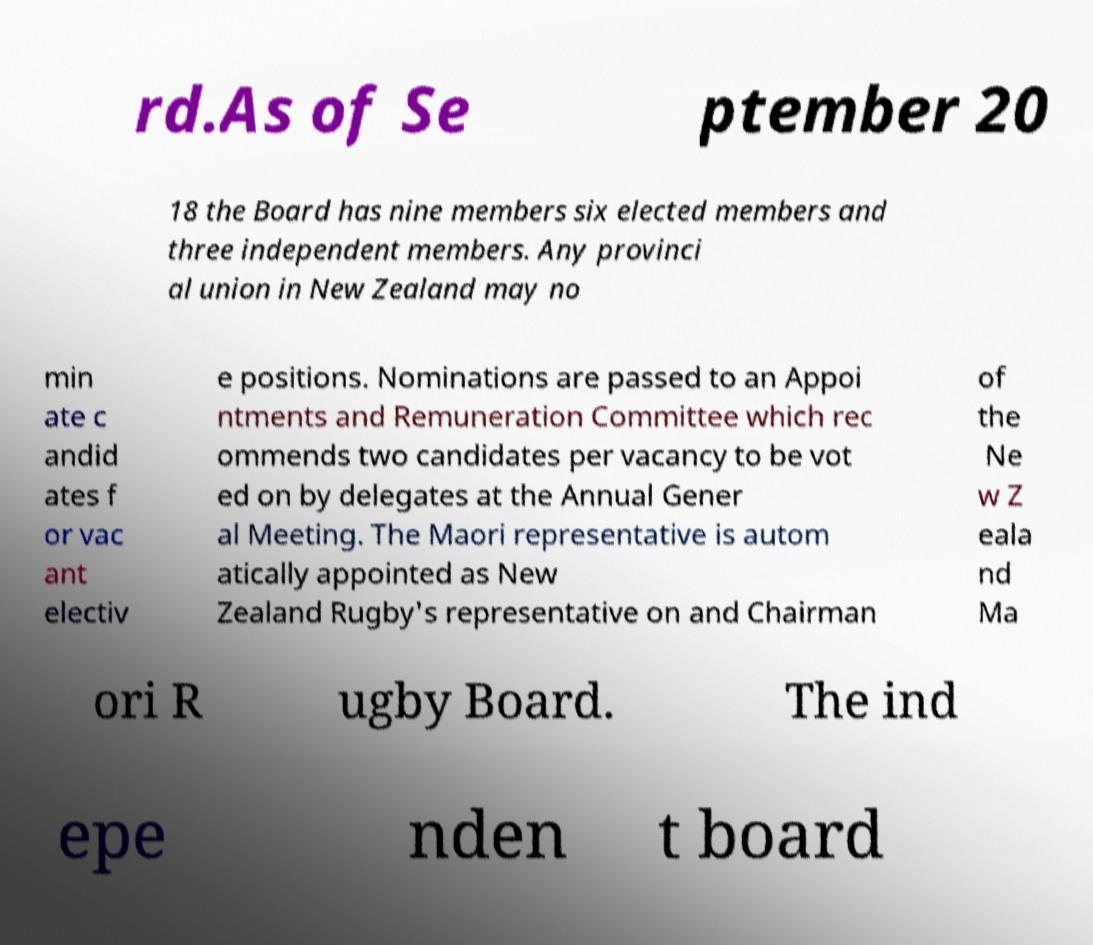Please read and relay the text visible in this image. What does it say? rd.As of Se ptember 20 18 the Board has nine members six elected members and three independent members. Any provinci al union in New Zealand may no min ate c andid ates f or vac ant electiv e positions. Nominations are passed to an Appoi ntments and Remuneration Committee which rec ommends two candidates per vacancy to be vot ed on by delegates at the Annual Gener al Meeting. The Maori representative is autom atically appointed as New Zealand Rugby's representative on and Chairman of the Ne w Z eala nd Ma ori R ugby Board. The ind epe nden t board 